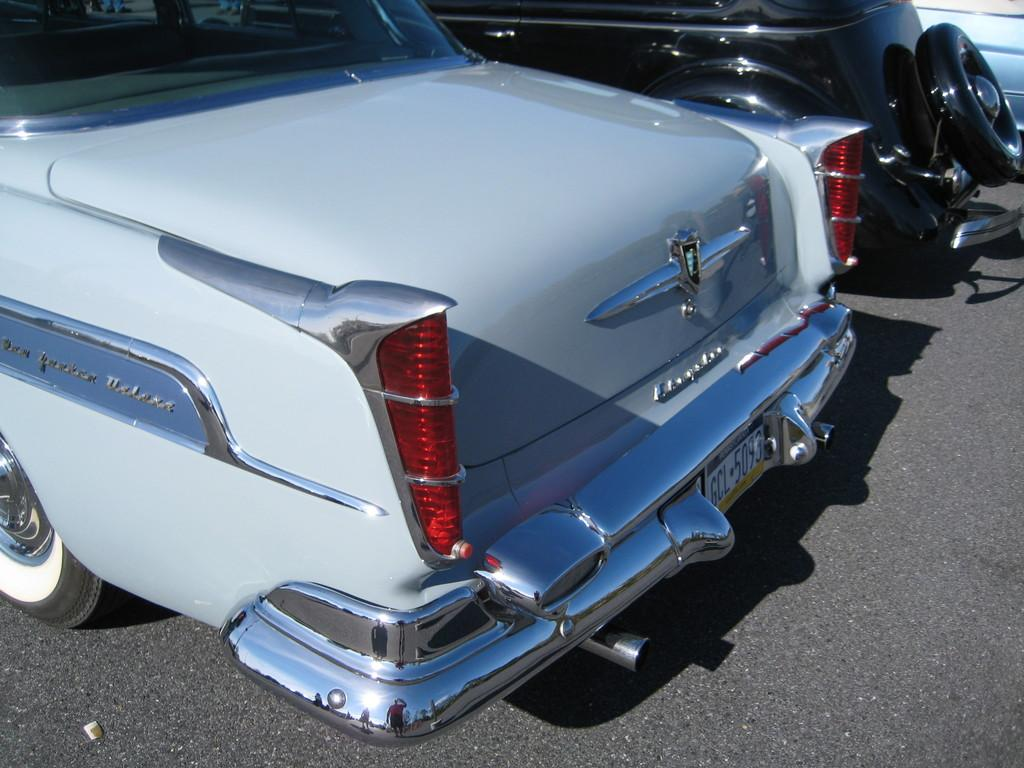What type of vehicles can be seen on the road in the image? There are cars present on the road in the image. Can you describe the setting in which the cars are located? The cars are on a road, which suggests that they are in a transportation-related environment. How many cars can be seen in the image? The number of cars visible in the image is not specified, but there are at least some cars present on the road. What type of insect can be seen flying over the crowd in the image? There is no crowd or insect present in the image; it only features cars on a road. 